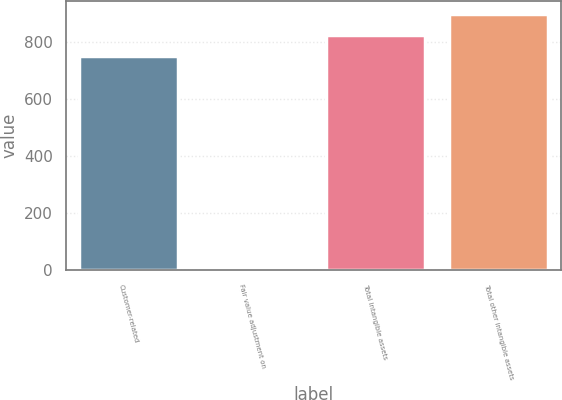Convert chart to OTSL. <chart><loc_0><loc_0><loc_500><loc_500><bar_chart><fcel>Customer-related<fcel>Fair value adjustment on<fcel>Total intangible assets<fcel>Total other intangible assets<nl><fcel>751<fcel>4<fcel>826.1<fcel>901.2<nl></chart> 